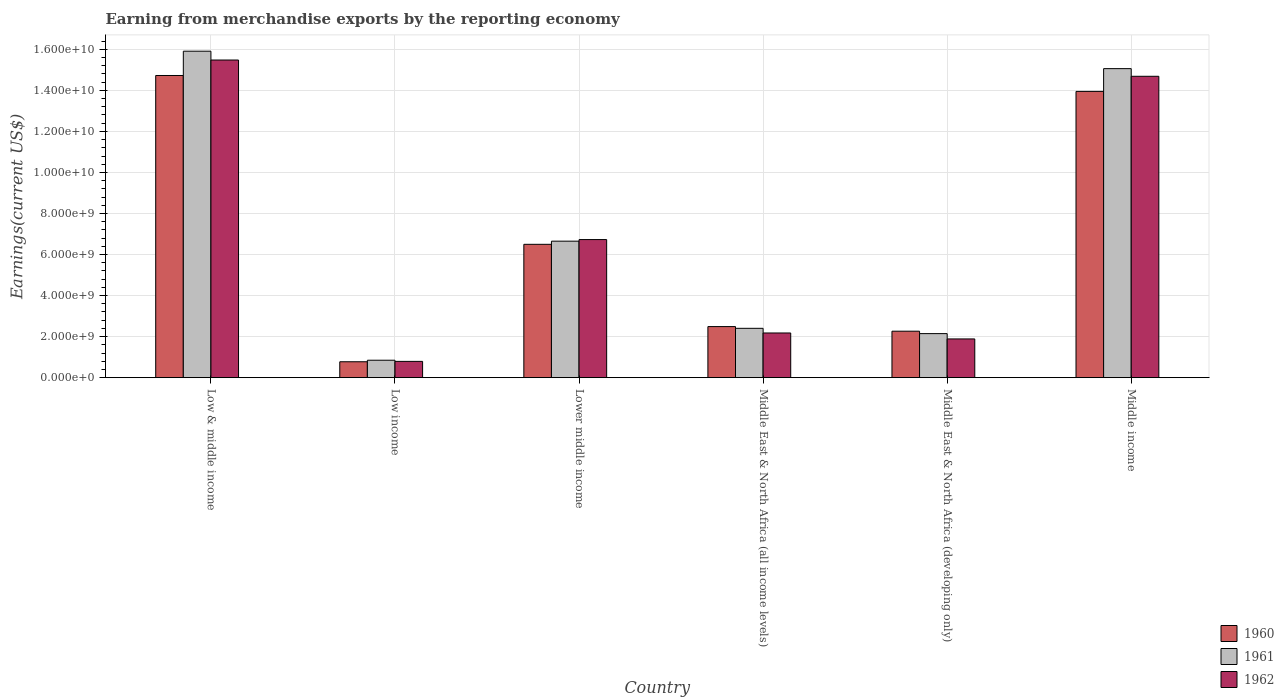How many different coloured bars are there?
Offer a very short reply. 3. How many groups of bars are there?
Offer a terse response. 6. How many bars are there on the 6th tick from the left?
Provide a short and direct response. 3. What is the label of the 5th group of bars from the left?
Your answer should be very brief. Middle East & North Africa (developing only). In how many cases, is the number of bars for a given country not equal to the number of legend labels?
Give a very brief answer. 0. What is the amount earned from merchandise exports in 1961 in Low & middle income?
Your response must be concise. 1.59e+1. Across all countries, what is the maximum amount earned from merchandise exports in 1961?
Give a very brief answer. 1.59e+1. Across all countries, what is the minimum amount earned from merchandise exports in 1962?
Ensure brevity in your answer.  7.93e+08. What is the total amount earned from merchandise exports in 1962 in the graph?
Your response must be concise. 4.17e+1. What is the difference between the amount earned from merchandise exports in 1962 in Low & middle income and that in Low income?
Offer a very short reply. 1.47e+1. What is the difference between the amount earned from merchandise exports in 1961 in Low & middle income and the amount earned from merchandise exports in 1962 in Middle East & North Africa (developing only)?
Offer a very short reply. 1.40e+1. What is the average amount earned from merchandise exports in 1961 per country?
Ensure brevity in your answer.  7.17e+09. What is the difference between the amount earned from merchandise exports of/in 1961 and amount earned from merchandise exports of/in 1962 in Middle income?
Make the answer very short. 3.73e+08. What is the ratio of the amount earned from merchandise exports in 1962 in Low income to that in Middle East & North Africa (developing only)?
Keep it short and to the point. 0.42. What is the difference between the highest and the second highest amount earned from merchandise exports in 1960?
Offer a very short reply. 7.75e+08. What is the difference between the highest and the lowest amount earned from merchandise exports in 1961?
Keep it short and to the point. 1.51e+1. What does the 1st bar from the left in Middle East & North Africa (developing only) represents?
Provide a short and direct response. 1960. What does the 3rd bar from the right in Middle East & North Africa (developing only) represents?
Offer a very short reply. 1960. Are all the bars in the graph horizontal?
Provide a short and direct response. No. Does the graph contain grids?
Give a very brief answer. Yes. What is the title of the graph?
Offer a very short reply. Earning from merchandise exports by the reporting economy. Does "2012" appear as one of the legend labels in the graph?
Provide a succinct answer. No. What is the label or title of the X-axis?
Make the answer very short. Country. What is the label or title of the Y-axis?
Your answer should be very brief. Earnings(current US$). What is the Earnings(current US$) in 1960 in Low & middle income?
Your answer should be compact. 1.47e+1. What is the Earnings(current US$) in 1961 in Low & middle income?
Your answer should be compact. 1.59e+1. What is the Earnings(current US$) of 1962 in Low & middle income?
Ensure brevity in your answer.  1.55e+1. What is the Earnings(current US$) in 1960 in Low income?
Keep it short and to the point. 7.75e+08. What is the Earnings(current US$) in 1961 in Low income?
Offer a terse response. 8.50e+08. What is the Earnings(current US$) in 1962 in Low income?
Provide a short and direct response. 7.93e+08. What is the Earnings(current US$) of 1960 in Lower middle income?
Your answer should be compact. 6.50e+09. What is the Earnings(current US$) of 1961 in Lower middle income?
Your response must be concise. 6.65e+09. What is the Earnings(current US$) in 1962 in Lower middle income?
Keep it short and to the point. 6.73e+09. What is the Earnings(current US$) in 1960 in Middle East & North Africa (all income levels)?
Keep it short and to the point. 2.49e+09. What is the Earnings(current US$) in 1961 in Middle East & North Africa (all income levels)?
Provide a succinct answer. 2.40e+09. What is the Earnings(current US$) of 1962 in Middle East & North Africa (all income levels)?
Offer a terse response. 2.18e+09. What is the Earnings(current US$) in 1960 in Middle East & North Africa (developing only)?
Provide a short and direct response. 2.26e+09. What is the Earnings(current US$) in 1961 in Middle East & North Africa (developing only)?
Your response must be concise. 2.15e+09. What is the Earnings(current US$) of 1962 in Middle East & North Africa (developing only)?
Offer a terse response. 1.89e+09. What is the Earnings(current US$) of 1960 in Middle income?
Your answer should be compact. 1.39e+1. What is the Earnings(current US$) of 1961 in Middle income?
Give a very brief answer. 1.51e+1. What is the Earnings(current US$) of 1962 in Middle income?
Offer a very short reply. 1.47e+1. Across all countries, what is the maximum Earnings(current US$) of 1960?
Offer a terse response. 1.47e+1. Across all countries, what is the maximum Earnings(current US$) of 1961?
Provide a succinct answer. 1.59e+1. Across all countries, what is the maximum Earnings(current US$) of 1962?
Offer a very short reply. 1.55e+1. Across all countries, what is the minimum Earnings(current US$) in 1960?
Your response must be concise. 7.75e+08. Across all countries, what is the minimum Earnings(current US$) of 1961?
Your response must be concise. 8.50e+08. Across all countries, what is the minimum Earnings(current US$) in 1962?
Make the answer very short. 7.93e+08. What is the total Earnings(current US$) of 1960 in the graph?
Provide a short and direct response. 4.07e+1. What is the total Earnings(current US$) in 1961 in the graph?
Your response must be concise. 4.30e+1. What is the total Earnings(current US$) in 1962 in the graph?
Give a very brief answer. 4.17e+1. What is the difference between the Earnings(current US$) in 1960 in Low & middle income and that in Low income?
Offer a terse response. 1.39e+1. What is the difference between the Earnings(current US$) in 1961 in Low & middle income and that in Low income?
Keep it short and to the point. 1.51e+1. What is the difference between the Earnings(current US$) of 1962 in Low & middle income and that in Low income?
Your answer should be compact. 1.47e+1. What is the difference between the Earnings(current US$) in 1960 in Low & middle income and that in Lower middle income?
Make the answer very short. 8.23e+09. What is the difference between the Earnings(current US$) in 1961 in Low & middle income and that in Lower middle income?
Keep it short and to the point. 9.26e+09. What is the difference between the Earnings(current US$) in 1962 in Low & middle income and that in Lower middle income?
Your response must be concise. 8.75e+09. What is the difference between the Earnings(current US$) of 1960 in Low & middle income and that in Middle East & North Africa (all income levels)?
Your answer should be compact. 1.22e+1. What is the difference between the Earnings(current US$) of 1961 in Low & middle income and that in Middle East & North Africa (all income levels)?
Provide a succinct answer. 1.35e+1. What is the difference between the Earnings(current US$) of 1962 in Low & middle income and that in Middle East & North Africa (all income levels)?
Keep it short and to the point. 1.33e+1. What is the difference between the Earnings(current US$) in 1960 in Low & middle income and that in Middle East & North Africa (developing only)?
Your response must be concise. 1.25e+1. What is the difference between the Earnings(current US$) in 1961 in Low & middle income and that in Middle East & North Africa (developing only)?
Your answer should be very brief. 1.38e+1. What is the difference between the Earnings(current US$) of 1962 in Low & middle income and that in Middle East & North Africa (developing only)?
Give a very brief answer. 1.36e+1. What is the difference between the Earnings(current US$) of 1960 in Low & middle income and that in Middle income?
Provide a succinct answer. 7.75e+08. What is the difference between the Earnings(current US$) in 1961 in Low & middle income and that in Middle income?
Your answer should be compact. 8.50e+08. What is the difference between the Earnings(current US$) in 1962 in Low & middle income and that in Middle income?
Your answer should be compact. 7.93e+08. What is the difference between the Earnings(current US$) in 1960 in Low income and that in Lower middle income?
Keep it short and to the point. -5.72e+09. What is the difference between the Earnings(current US$) in 1961 in Low income and that in Lower middle income?
Your answer should be very brief. -5.80e+09. What is the difference between the Earnings(current US$) of 1962 in Low income and that in Lower middle income?
Offer a very short reply. -5.94e+09. What is the difference between the Earnings(current US$) in 1960 in Low income and that in Middle East & North Africa (all income levels)?
Offer a very short reply. -1.71e+09. What is the difference between the Earnings(current US$) in 1961 in Low income and that in Middle East & North Africa (all income levels)?
Your answer should be very brief. -1.55e+09. What is the difference between the Earnings(current US$) of 1962 in Low income and that in Middle East & North Africa (all income levels)?
Offer a terse response. -1.38e+09. What is the difference between the Earnings(current US$) in 1960 in Low income and that in Middle East & North Africa (developing only)?
Give a very brief answer. -1.49e+09. What is the difference between the Earnings(current US$) in 1961 in Low income and that in Middle East & North Africa (developing only)?
Your response must be concise. -1.30e+09. What is the difference between the Earnings(current US$) in 1962 in Low income and that in Middle East & North Africa (developing only)?
Provide a succinct answer. -1.09e+09. What is the difference between the Earnings(current US$) of 1960 in Low income and that in Middle income?
Offer a terse response. -1.32e+1. What is the difference between the Earnings(current US$) of 1961 in Low income and that in Middle income?
Your answer should be very brief. -1.42e+1. What is the difference between the Earnings(current US$) of 1962 in Low income and that in Middle income?
Make the answer very short. -1.39e+1. What is the difference between the Earnings(current US$) of 1960 in Lower middle income and that in Middle East & North Africa (all income levels)?
Your response must be concise. 4.01e+09. What is the difference between the Earnings(current US$) of 1961 in Lower middle income and that in Middle East & North Africa (all income levels)?
Your answer should be compact. 4.25e+09. What is the difference between the Earnings(current US$) of 1962 in Lower middle income and that in Middle East & North Africa (all income levels)?
Ensure brevity in your answer.  4.55e+09. What is the difference between the Earnings(current US$) of 1960 in Lower middle income and that in Middle East & North Africa (developing only)?
Provide a succinct answer. 4.23e+09. What is the difference between the Earnings(current US$) in 1961 in Lower middle income and that in Middle East & North Africa (developing only)?
Offer a terse response. 4.51e+09. What is the difference between the Earnings(current US$) of 1962 in Lower middle income and that in Middle East & North Africa (developing only)?
Offer a very short reply. 4.84e+09. What is the difference between the Earnings(current US$) of 1960 in Lower middle income and that in Middle income?
Make the answer very short. -7.45e+09. What is the difference between the Earnings(current US$) in 1961 in Lower middle income and that in Middle income?
Keep it short and to the point. -8.41e+09. What is the difference between the Earnings(current US$) of 1962 in Lower middle income and that in Middle income?
Offer a very short reply. -7.96e+09. What is the difference between the Earnings(current US$) in 1960 in Middle East & North Africa (all income levels) and that in Middle East & North Africa (developing only)?
Offer a terse response. 2.25e+08. What is the difference between the Earnings(current US$) of 1961 in Middle East & North Africa (all income levels) and that in Middle East & North Africa (developing only)?
Provide a succinct answer. 2.58e+08. What is the difference between the Earnings(current US$) of 1962 in Middle East & North Africa (all income levels) and that in Middle East & North Africa (developing only)?
Provide a short and direct response. 2.90e+08. What is the difference between the Earnings(current US$) of 1960 in Middle East & North Africa (all income levels) and that in Middle income?
Offer a terse response. -1.15e+1. What is the difference between the Earnings(current US$) of 1961 in Middle East & North Africa (all income levels) and that in Middle income?
Give a very brief answer. -1.27e+1. What is the difference between the Earnings(current US$) of 1962 in Middle East & North Africa (all income levels) and that in Middle income?
Your answer should be compact. -1.25e+1. What is the difference between the Earnings(current US$) of 1960 in Middle East & North Africa (developing only) and that in Middle income?
Your response must be concise. -1.17e+1. What is the difference between the Earnings(current US$) in 1961 in Middle East & North Africa (developing only) and that in Middle income?
Keep it short and to the point. -1.29e+1. What is the difference between the Earnings(current US$) in 1962 in Middle East & North Africa (developing only) and that in Middle income?
Offer a very short reply. -1.28e+1. What is the difference between the Earnings(current US$) in 1960 in Low & middle income and the Earnings(current US$) in 1961 in Low income?
Offer a terse response. 1.39e+1. What is the difference between the Earnings(current US$) of 1960 in Low & middle income and the Earnings(current US$) of 1962 in Low income?
Give a very brief answer. 1.39e+1. What is the difference between the Earnings(current US$) in 1961 in Low & middle income and the Earnings(current US$) in 1962 in Low income?
Make the answer very short. 1.51e+1. What is the difference between the Earnings(current US$) in 1960 in Low & middle income and the Earnings(current US$) in 1961 in Lower middle income?
Keep it short and to the point. 8.07e+09. What is the difference between the Earnings(current US$) in 1960 in Low & middle income and the Earnings(current US$) in 1962 in Lower middle income?
Keep it short and to the point. 8.00e+09. What is the difference between the Earnings(current US$) in 1961 in Low & middle income and the Earnings(current US$) in 1962 in Lower middle income?
Provide a succinct answer. 9.18e+09. What is the difference between the Earnings(current US$) in 1960 in Low & middle income and the Earnings(current US$) in 1961 in Middle East & North Africa (all income levels)?
Your answer should be compact. 1.23e+1. What is the difference between the Earnings(current US$) in 1960 in Low & middle income and the Earnings(current US$) in 1962 in Middle East & North Africa (all income levels)?
Keep it short and to the point. 1.25e+1. What is the difference between the Earnings(current US$) in 1961 in Low & middle income and the Earnings(current US$) in 1962 in Middle East & North Africa (all income levels)?
Keep it short and to the point. 1.37e+1. What is the difference between the Earnings(current US$) of 1960 in Low & middle income and the Earnings(current US$) of 1961 in Middle East & North Africa (developing only)?
Your answer should be compact. 1.26e+1. What is the difference between the Earnings(current US$) of 1960 in Low & middle income and the Earnings(current US$) of 1962 in Middle East & North Africa (developing only)?
Provide a succinct answer. 1.28e+1. What is the difference between the Earnings(current US$) of 1961 in Low & middle income and the Earnings(current US$) of 1962 in Middle East & North Africa (developing only)?
Keep it short and to the point. 1.40e+1. What is the difference between the Earnings(current US$) of 1960 in Low & middle income and the Earnings(current US$) of 1961 in Middle income?
Offer a very short reply. -3.34e+08. What is the difference between the Earnings(current US$) of 1960 in Low & middle income and the Earnings(current US$) of 1962 in Middle income?
Offer a terse response. 3.94e+07. What is the difference between the Earnings(current US$) in 1961 in Low & middle income and the Earnings(current US$) in 1962 in Middle income?
Your answer should be very brief. 1.22e+09. What is the difference between the Earnings(current US$) in 1960 in Low income and the Earnings(current US$) in 1961 in Lower middle income?
Make the answer very short. -5.88e+09. What is the difference between the Earnings(current US$) of 1960 in Low income and the Earnings(current US$) of 1962 in Lower middle income?
Your answer should be compact. -5.95e+09. What is the difference between the Earnings(current US$) in 1961 in Low income and the Earnings(current US$) in 1962 in Lower middle income?
Give a very brief answer. -5.88e+09. What is the difference between the Earnings(current US$) in 1960 in Low income and the Earnings(current US$) in 1961 in Middle East & North Africa (all income levels)?
Provide a succinct answer. -1.63e+09. What is the difference between the Earnings(current US$) in 1960 in Low income and the Earnings(current US$) in 1962 in Middle East & North Africa (all income levels)?
Your response must be concise. -1.40e+09. What is the difference between the Earnings(current US$) of 1961 in Low income and the Earnings(current US$) of 1962 in Middle East & North Africa (all income levels)?
Your answer should be compact. -1.33e+09. What is the difference between the Earnings(current US$) of 1960 in Low income and the Earnings(current US$) of 1961 in Middle East & North Africa (developing only)?
Ensure brevity in your answer.  -1.37e+09. What is the difference between the Earnings(current US$) of 1960 in Low income and the Earnings(current US$) of 1962 in Middle East & North Africa (developing only)?
Your answer should be compact. -1.11e+09. What is the difference between the Earnings(current US$) of 1961 in Low income and the Earnings(current US$) of 1962 in Middle East & North Africa (developing only)?
Offer a very short reply. -1.04e+09. What is the difference between the Earnings(current US$) in 1960 in Low income and the Earnings(current US$) in 1961 in Middle income?
Make the answer very short. -1.43e+1. What is the difference between the Earnings(current US$) in 1960 in Low income and the Earnings(current US$) in 1962 in Middle income?
Offer a terse response. -1.39e+1. What is the difference between the Earnings(current US$) of 1961 in Low income and the Earnings(current US$) of 1962 in Middle income?
Offer a very short reply. -1.38e+1. What is the difference between the Earnings(current US$) of 1960 in Lower middle income and the Earnings(current US$) of 1961 in Middle East & North Africa (all income levels)?
Offer a very short reply. 4.09e+09. What is the difference between the Earnings(current US$) in 1960 in Lower middle income and the Earnings(current US$) in 1962 in Middle East & North Africa (all income levels)?
Provide a succinct answer. 4.32e+09. What is the difference between the Earnings(current US$) of 1961 in Lower middle income and the Earnings(current US$) of 1962 in Middle East & North Africa (all income levels)?
Your answer should be compact. 4.47e+09. What is the difference between the Earnings(current US$) in 1960 in Lower middle income and the Earnings(current US$) in 1961 in Middle East & North Africa (developing only)?
Your answer should be compact. 4.35e+09. What is the difference between the Earnings(current US$) of 1960 in Lower middle income and the Earnings(current US$) of 1962 in Middle East & North Africa (developing only)?
Offer a terse response. 4.61e+09. What is the difference between the Earnings(current US$) of 1961 in Lower middle income and the Earnings(current US$) of 1962 in Middle East & North Africa (developing only)?
Provide a short and direct response. 4.76e+09. What is the difference between the Earnings(current US$) of 1960 in Lower middle income and the Earnings(current US$) of 1961 in Middle income?
Offer a very short reply. -8.56e+09. What is the difference between the Earnings(current US$) of 1960 in Lower middle income and the Earnings(current US$) of 1962 in Middle income?
Provide a succinct answer. -8.19e+09. What is the difference between the Earnings(current US$) of 1961 in Lower middle income and the Earnings(current US$) of 1962 in Middle income?
Offer a very short reply. -8.03e+09. What is the difference between the Earnings(current US$) in 1960 in Middle East & North Africa (all income levels) and the Earnings(current US$) in 1961 in Middle East & North Africa (developing only)?
Your answer should be very brief. 3.43e+08. What is the difference between the Earnings(current US$) of 1960 in Middle East & North Africa (all income levels) and the Earnings(current US$) of 1962 in Middle East & North Africa (developing only)?
Make the answer very short. 6.02e+08. What is the difference between the Earnings(current US$) of 1961 in Middle East & North Africa (all income levels) and the Earnings(current US$) of 1962 in Middle East & North Africa (developing only)?
Give a very brief answer. 5.17e+08. What is the difference between the Earnings(current US$) in 1960 in Middle East & North Africa (all income levels) and the Earnings(current US$) in 1961 in Middle income?
Provide a short and direct response. -1.26e+1. What is the difference between the Earnings(current US$) of 1960 in Middle East & North Africa (all income levels) and the Earnings(current US$) of 1962 in Middle income?
Your response must be concise. -1.22e+1. What is the difference between the Earnings(current US$) of 1961 in Middle East & North Africa (all income levels) and the Earnings(current US$) of 1962 in Middle income?
Your response must be concise. -1.23e+1. What is the difference between the Earnings(current US$) of 1960 in Middle East & North Africa (developing only) and the Earnings(current US$) of 1961 in Middle income?
Keep it short and to the point. -1.28e+1. What is the difference between the Earnings(current US$) in 1960 in Middle East & North Africa (developing only) and the Earnings(current US$) in 1962 in Middle income?
Offer a terse response. -1.24e+1. What is the difference between the Earnings(current US$) in 1961 in Middle East & North Africa (developing only) and the Earnings(current US$) in 1962 in Middle income?
Offer a very short reply. -1.25e+1. What is the average Earnings(current US$) of 1960 per country?
Your response must be concise. 6.78e+09. What is the average Earnings(current US$) in 1961 per country?
Provide a short and direct response. 7.17e+09. What is the average Earnings(current US$) of 1962 per country?
Give a very brief answer. 6.96e+09. What is the difference between the Earnings(current US$) of 1960 and Earnings(current US$) of 1961 in Low & middle income?
Ensure brevity in your answer.  -1.18e+09. What is the difference between the Earnings(current US$) in 1960 and Earnings(current US$) in 1962 in Low & middle income?
Your answer should be compact. -7.54e+08. What is the difference between the Earnings(current US$) in 1961 and Earnings(current US$) in 1962 in Low & middle income?
Your answer should be very brief. 4.30e+08. What is the difference between the Earnings(current US$) of 1960 and Earnings(current US$) of 1961 in Low income?
Your answer should be very brief. -7.47e+07. What is the difference between the Earnings(current US$) of 1960 and Earnings(current US$) of 1962 in Low income?
Make the answer very short. -1.80e+07. What is the difference between the Earnings(current US$) in 1961 and Earnings(current US$) in 1962 in Low income?
Your response must be concise. 5.66e+07. What is the difference between the Earnings(current US$) of 1960 and Earnings(current US$) of 1961 in Lower middle income?
Offer a very short reply. -1.54e+08. What is the difference between the Earnings(current US$) in 1960 and Earnings(current US$) in 1962 in Lower middle income?
Make the answer very short. -2.31e+08. What is the difference between the Earnings(current US$) in 1961 and Earnings(current US$) in 1962 in Lower middle income?
Make the answer very short. -7.70e+07. What is the difference between the Earnings(current US$) in 1960 and Earnings(current US$) in 1961 in Middle East & North Africa (all income levels)?
Your answer should be very brief. 8.50e+07. What is the difference between the Earnings(current US$) in 1960 and Earnings(current US$) in 1962 in Middle East & North Africa (all income levels)?
Offer a terse response. 3.12e+08. What is the difference between the Earnings(current US$) of 1961 and Earnings(current US$) of 1962 in Middle East & North Africa (all income levels)?
Keep it short and to the point. 2.27e+08. What is the difference between the Earnings(current US$) of 1960 and Earnings(current US$) of 1961 in Middle East & North Africa (developing only)?
Keep it short and to the point. 1.18e+08. What is the difference between the Earnings(current US$) of 1960 and Earnings(current US$) of 1962 in Middle East & North Africa (developing only)?
Make the answer very short. 3.77e+08. What is the difference between the Earnings(current US$) of 1961 and Earnings(current US$) of 1962 in Middle East & North Africa (developing only)?
Provide a short and direct response. 2.59e+08. What is the difference between the Earnings(current US$) of 1960 and Earnings(current US$) of 1961 in Middle income?
Make the answer very short. -1.11e+09. What is the difference between the Earnings(current US$) in 1960 and Earnings(current US$) in 1962 in Middle income?
Give a very brief answer. -7.36e+08. What is the difference between the Earnings(current US$) in 1961 and Earnings(current US$) in 1962 in Middle income?
Your answer should be compact. 3.73e+08. What is the ratio of the Earnings(current US$) of 1960 in Low & middle income to that in Low income?
Ensure brevity in your answer.  19. What is the ratio of the Earnings(current US$) in 1961 in Low & middle income to that in Low income?
Offer a very short reply. 18.72. What is the ratio of the Earnings(current US$) in 1962 in Low & middle income to that in Low income?
Your answer should be very brief. 19.51. What is the ratio of the Earnings(current US$) of 1960 in Low & middle income to that in Lower middle income?
Ensure brevity in your answer.  2.27. What is the ratio of the Earnings(current US$) in 1961 in Low & middle income to that in Lower middle income?
Keep it short and to the point. 2.39. What is the ratio of the Earnings(current US$) in 1962 in Low & middle income to that in Lower middle income?
Your answer should be very brief. 2.3. What is the ratio of the Earnings(current US$) in 1960 in Low & middle income to that in Middle East & North Africa (all income levels)?
Your answer should be very brief. 5.92. What is the ratio of the Earnings(current US$) of 1961 in Low & middle income to that in Middle East & North Africa (all income levels)?
Provide a short and direct response. 6.62. What is the ratio of the Earnings(current US$) in 1962 in Low & middle income to that in Middle East & North Africa (all income levels)?
Ensure brevity in your answer.  7.11. What is the ratio of the Earnings(current US$) in 1960 in Low & middle income to that in Middle East & North Africa (developing only)?
Keep it short and to the point. 6.5. What is the ratio of the Earnings(current US$) of 1961 in Low & middle income to that in Middle East & North Africa (developing only)?
Offer a terse response. 7.41. What is the ratio of the Earnings(current US$) in 1962 in Low & middle income to that in Middle East & North Africa (developing only)?
Keep it short and to the point. 8.2. What is the ratio of the Earnings(current US$) in 1960 in Low & middle income to that in Middle income?
Give a very brief answer. 1.06. What is the ratio of the Earnings(current US$) in 1961 in Low & middle income to that in Middle income?
Offer a very short reply. 1.06. What is the ratio of the Earnings(current US$) of 1962 in Low & middle income to that in Middle income?
Your answer should be very brief. 1.05. What is the ratio of the Earnings(current US$) of 1960 in Low income to that in Lower middle income?
Your answer should be very brief. 0.12. What is the ratio of the Earnings(current US$) in 1961 in Low income to that in Lower middle income?
Provide a short and direct response. 0.13. What is the ratio of the Earnings(current US$) of 1962 in Low income to that in Lower middle income?
Your answer should be compact. 0.12. What is the ratio of the Earnings(current US$) of 1960 in Low income to that in Middle East & North Africa (all income levels)?
Keep it short and to the point. 0.31. What is the ratio of the Earnings(current US$) of 1961 in Low income to that in Middle East & North Africa (all income levels)?
Offer a very short reply. 0.35. What is the ratio of the Earnings(current US$) in 1962 in Low income to that in Middle East & North Africa (all income levels)?
Your answer should be compact. 0.36. What is the ratio of the Earnings(current US$) in 1960 in Low income to that in Middle East & North Africa (developing only)?
Ensure brevity in your answer.  0.34. What is the ratio of the Earnings(current US$) in 1961 in Low income to that in Middle East & North Africa (developing only)?
Your response must be concise. 0.4. What is the ratio of the Earnings(current US$) in 1962 in Low income to that in Middle East & North Africa (developing only)?
Offer a terse response. 0.42. What is the ratio of the Earnings(current US$) in 1960 in Low income to that in Middle income?
Offer a very short reply. 0.06. What is the ratio of the Earnings(current US$) of 1961 in Low income to that in Middle income?
Your answer should be very brief. 0.06. What is the ratio of the Earnings(current US$) in 1962 in Low income to that in Middle income?
Make the answer very short. 0.05. What is the ratio of the Earnings(current US$) of 1960 in Lower middle income to that in Middle East & North Africa (all income levels)?
Provide a short and direct response. 2.61. What is the ratio of the Earnings(current US$) in 1961 in Lower middle income to that in Middle East & North Africa (all income levels)?
Your answer should be compact. 2.77. What is the ratio of the Earnings(current US$) in 1962 in Lower middle income to that in Middle East & North Africa (all income levels)?
Give a very brief answer. 3.09. What is the ratio of the Earnings(current US$) in 1960 in Lower middle income to that in Middle East & North Africa (developing only)?
Ensure brevity in your answer.  2.87. What is the ratio of the Earnings(current US$) of 1961 in Lower middle income to that in Middle East & North Africa (developing only)?
Give a very brief answer. 3.1. What is the ratio of the Earnings(current US$) in 1962 in Lower middle income to that in Middle East & North Africa (developing only)?
Provide a succinct answer. 3.57. What is the ratio of the Earnings(current US$) in 1960 in Lower middle income to that in Middle income?
Your answer should be compact. 0.47. What is the ratio of the Earnings(current US$) of 1961 in Lower middle income to that in Middle income?
Your response must be concise. 0.44. What is the ratio of the Earnings(current US$) of 1962 in Lower middle income to that in Middle income?
Your response must be concise. 0.46. What is the ratio of the Earnings(current US$) in 1960 in Middle East & North Africa (all income levels) to that in Middle East & North Africa (developing only)?
Your response must be concise. 1.1. What is the ratio of the Earnings(current US$) in 1961 in Middle East & North Africa (all income levels) to that in Middle East & North Africa (developing only)?
Your answer should be very brief. 1.12. What is the ratio of the Earnings(current US$) in 1962 in Middle East & North Africa (all income levels) to that in Middle East & North Africa (developing only)?
Ensure brevity in your answer.  1.15. What is the ratio of the Earnings(current US$) of 1960 in Middle East & North Africa (all income levels) to that in Middle income?
Ensure brevity in your answer.  0.18. What is the ratio of the Earnings(current US$) in 1961 in Middle East & North Africa (all income levels) to that in Middle income?
Your response must be concise. 0.16. What is the ratio of the Earnings(current US$) in 1962 in Middle East & North Africa (all income levels) to that in Middle income?
Offer a very short reply. 0.15. What is the ratio of the Earnings(current US$) of 1960 in Middle East & North Africa (developing only) to that in Middle income?
Offer a very short reply. 0.16. What is the ratio of the Earnings(current US$) in 1961 in Middle East & North Africa (developing only) to that in Middle income?
Your answer should be compact. 0.14. What is the ratio of the Earnings(current US$) in 1962 in Middle East & North Africa (developing only) to that in Middle income?
Your response must be concise. 0.13. What is the difference between the highest and the second highest Earnings(current US$) in 1960?
Provide a succinct answer. 7.75e+08. What is the difference between the highest and the second highest Earnings(current US$) of 1961?
Give a very brief answer. 8.50e+08. What is the difference between the highest and the second highest Earnings(current US$) in 1962?
Your response must be concise. 7.93e+08. What is the difference between the highest and the lowest Earnings(current US$) of 1960?
Your response must be concise. 1.39e+1. What is the difference between the highest and the lowest Earnings(current US$) in 1961?
Offer a very short reply. 1.51e+1. What is the difference between the highest and the lowest Earnings(current US$) of 1962?
Your response must be concise. 1.47e+1. 